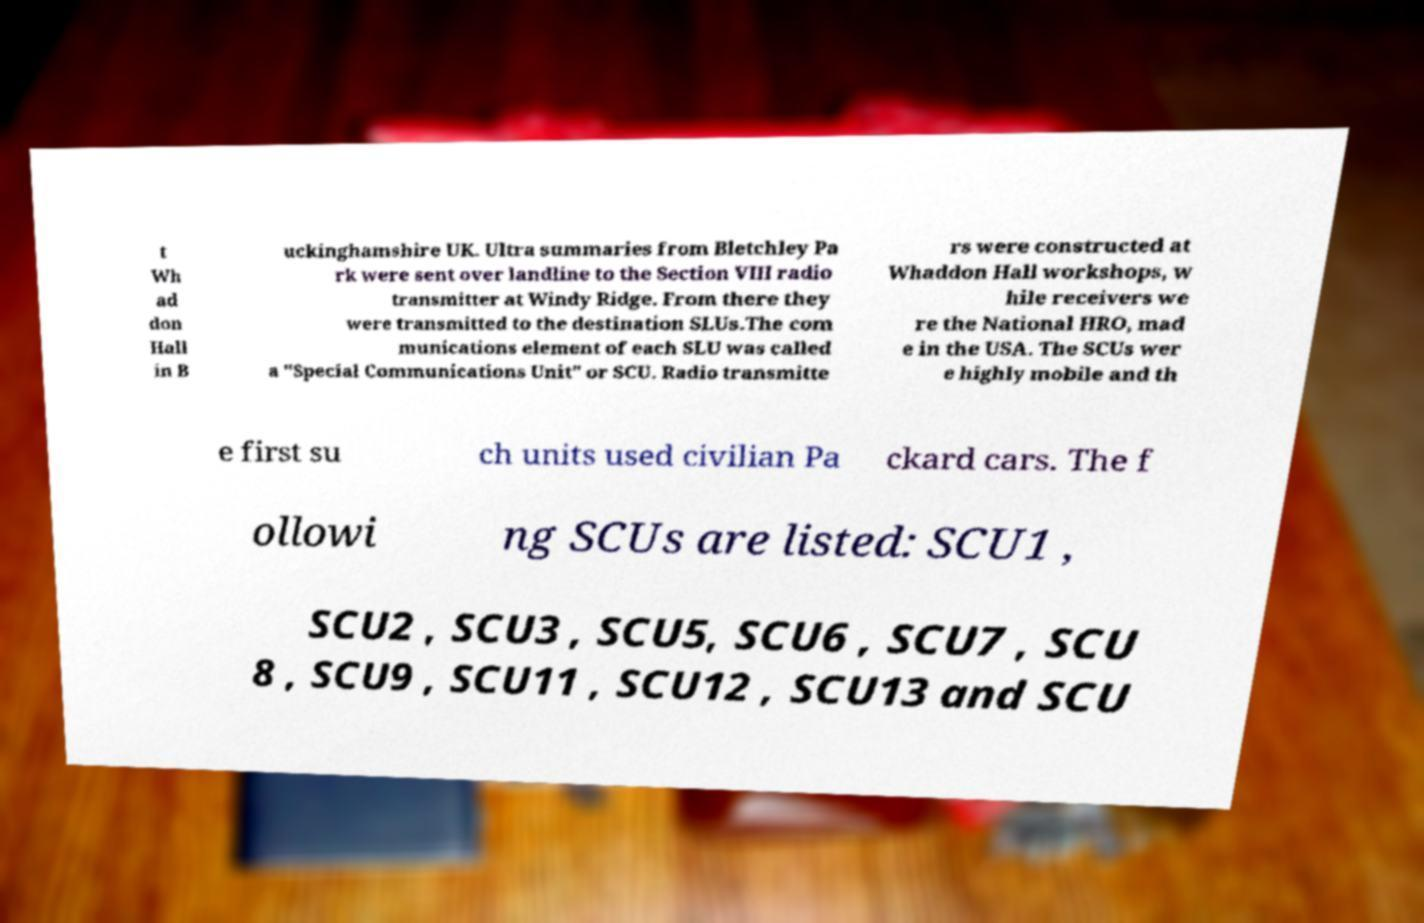Please read and relay the text visible in this image. What does it say? t Wh ad don Hall in B uckinghamshire UK. Ultra summaries from Bletchley Pa rk were sent over landline to the Section VIII radio transmitter at Windy Ridge. From there they were transmitted to the destination SLUs.The com munications element of each SLU was called a "Special Communications Unit" or SCU. Radio transmitte rs were constructed at Whaddon Hall workshops, w hile receivers we re the National HRO, mad e in the USA. The SCUs wer e highly mobile and th e first su ch units used civilian Pa ckard cars. The f ollowi ng SCUs are listed: SCU1 , SCU2 , SCU3 , SCU5, SCU6 , SCU7 , SCU 8 , SCU9 , SCU11 , SCU12 , SCU13 and SCU 